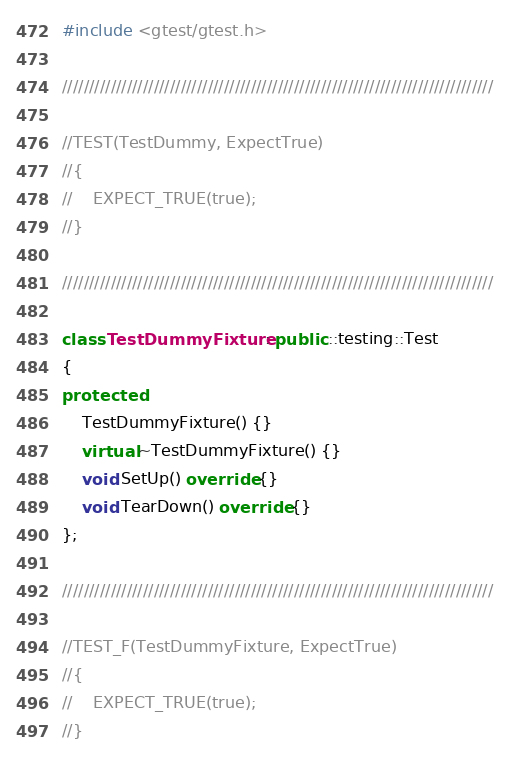<code> <loc_0><loc_0><loc_500><loc_500><_C++_>#include <gtest/gtest.h>

////////////////////////////////////////////////////////////////////////////////

//TEST(TestDummy, ExpectTrue)
//{
//    EXPECT_TRUE(true);
//}

////////////////////////////////////////////////////////////////////////////////

class TestDummyFixture : public ::testing::Test
{
protected:
    TestDummyFixture() {}
    virtual ~TestDummyFixture() {}
    void SetUp() override {}
    void TearDown() override {}
};

////////////////////////////////////////////////////////////////////////////////

//TEST_F(TestDummyFixture, ExpectTrue)
//{
//    EXPECT_TRUE(true);
//}
</code> 